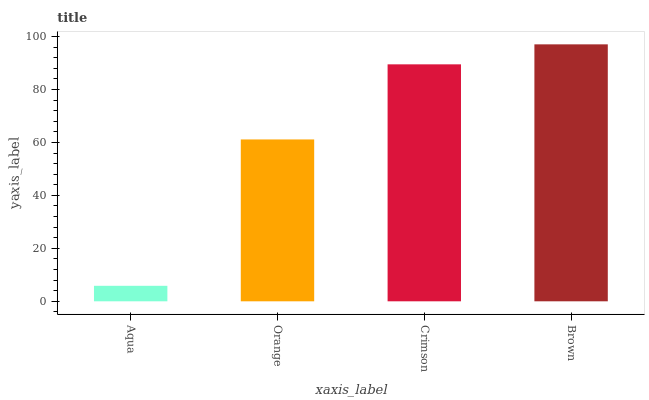Is Aqua the minimum?
Answer yes or no. Yes. Is Brown the maximum?
Answer yes or no. Yes. Is Orange the minimum?
Answer yes or no. No. Is Orange the maximum?
Answer yes or no. No. Is Orange greater than Aqua?
Answer yes or no. Yes. Is Aqua less than Orange?
Answer yes or no. Yes. Is Aqua greater than Orange?
Answer yes or no. No. Is Orange less than Aqua?
Answer yes or no. No. Is Crimson the high median?
Answer yes or no. Yes. Is Orange the low median?
Answer yes or no. Yes. Is Brown the high median?
Answer yes or no. No. Is Crimson the low median?
Answer yes or no. No. 